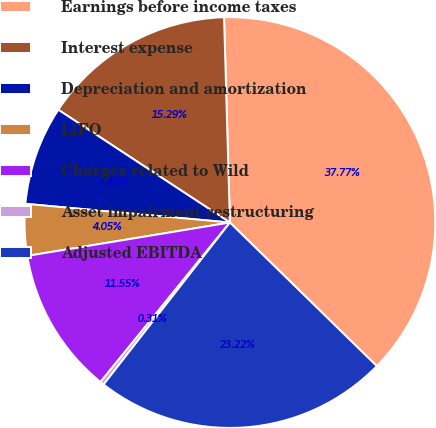Convert chart. <chart><loc_0><loc_0><loc_500><loc_500><pie_chart><fcel>Earnings before income taxes<fcel>Interest expense<fcel>Depreciation and amortization<fcel>LIFO<fcel>Charges related to Wild<fcel>Asset impairment restructuring<fcel>Adjusted EBITDA<nl><fcel>37.77%<fcel>15.29%<fcel>7.8%<fcel>4.05%<fcel>11.55%<fcel>0.31%<fcel>23.22%<nl></chart> 